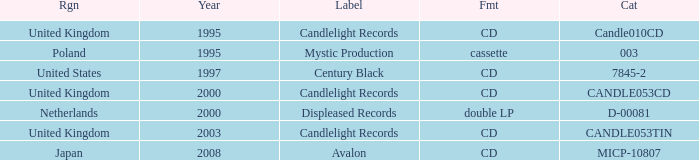What year did Japan form a label? 2008.0. 